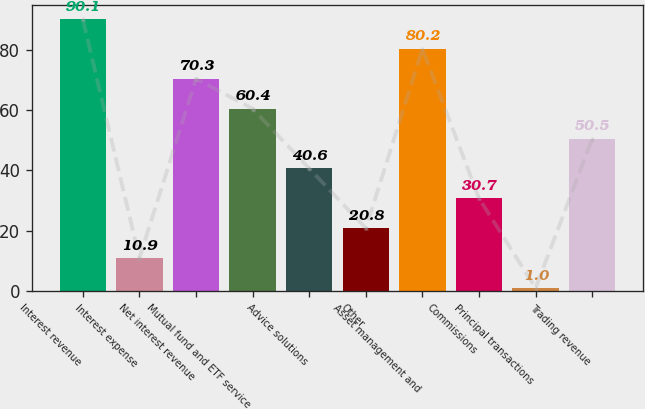Convert chart to OTSL. <chart><loc_0><loc_0><loc_500><loc_500><bar_chart><fcel>Interest revenue<fcel>Interest expense<fcel>Net interest revenue<fcel>Mutual fund and ETF service<fcel>Advice solutions<fcel>Other<fcel>Asset management and<fcel>Commissions<fcel>Principal transactions<fcel>Trading revenue<nl><fcel>90.1<fcel>10.9<fcel>70.3<fcel>60.4<fcel>40.6<fcel>20.8<fcel>80.2<fcel>30.7<fcel>1<fcel>50.5<nl></chart> 